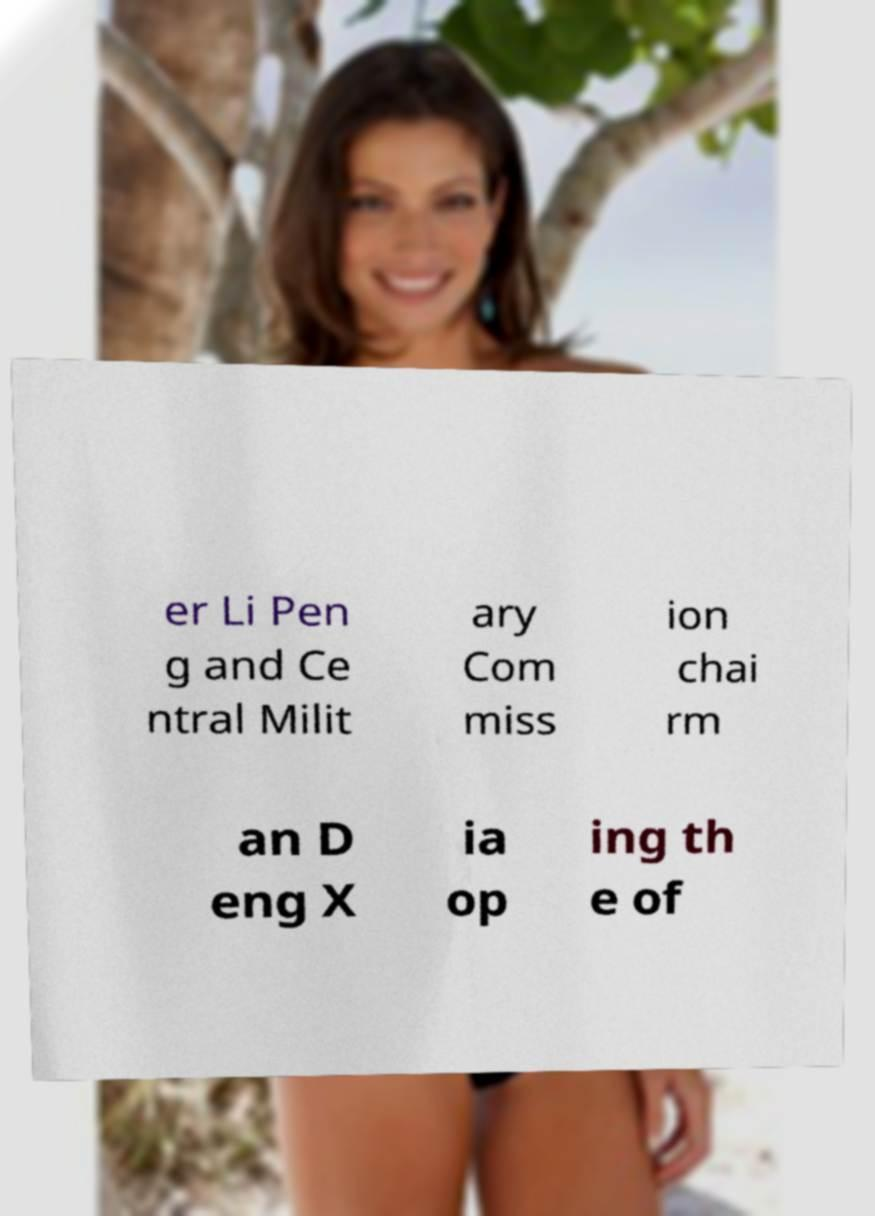Can you accurately transcribe the text from the provided image for me? er Li Pen g and Ce ntral Milit ary Com miss ion chai rm an D eng X ia op ing th e of 